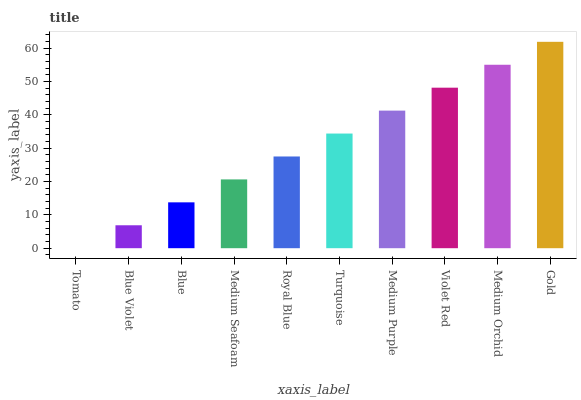Is Tomato the minimum?
Answer yes or no. Yes. Is Gold the maximum?
Answer yes or no. Yes. Is Blue Violet the minimum?
Answer yes or no. No. Is Blue Violet the maximum?
Answer yes or no. No. Is Blue Violet greater than Tomato?
Answer yes or no. Yes. Is Tomato less than Blue Violet?
Answer yes or no. Yes. Is Tomato greater than Blue Violet?
Answer yes or no. No. Is Blue Violet less than Tomato?
Answer yes or no. No. Is Turquoise the high median?
Answer yes or no. Yes. Is Royal Blue the low median?
Answer yes or no. Yes. Is Medium Seafoam the high median?
Answer yes or no. No. Is Gold the low median?
Answer yes or no. No. 